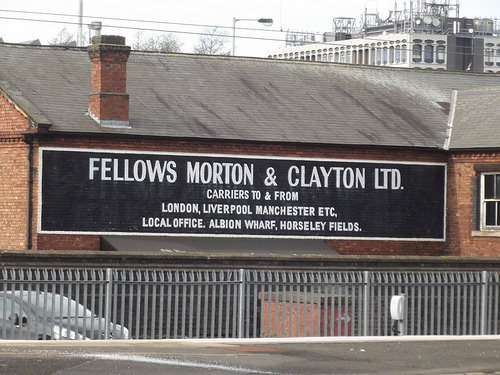<image>
Is the car behind the fence? Yes. From this viewpoint, the car is positioned behind the fence, with the fence partially or fully occluding the car. Where is the fence in relation to the car? Is it behind the car? No. The fence is not behind the car. From this viewpoint, the fence appears to be positioned elsewhere in the scene. 